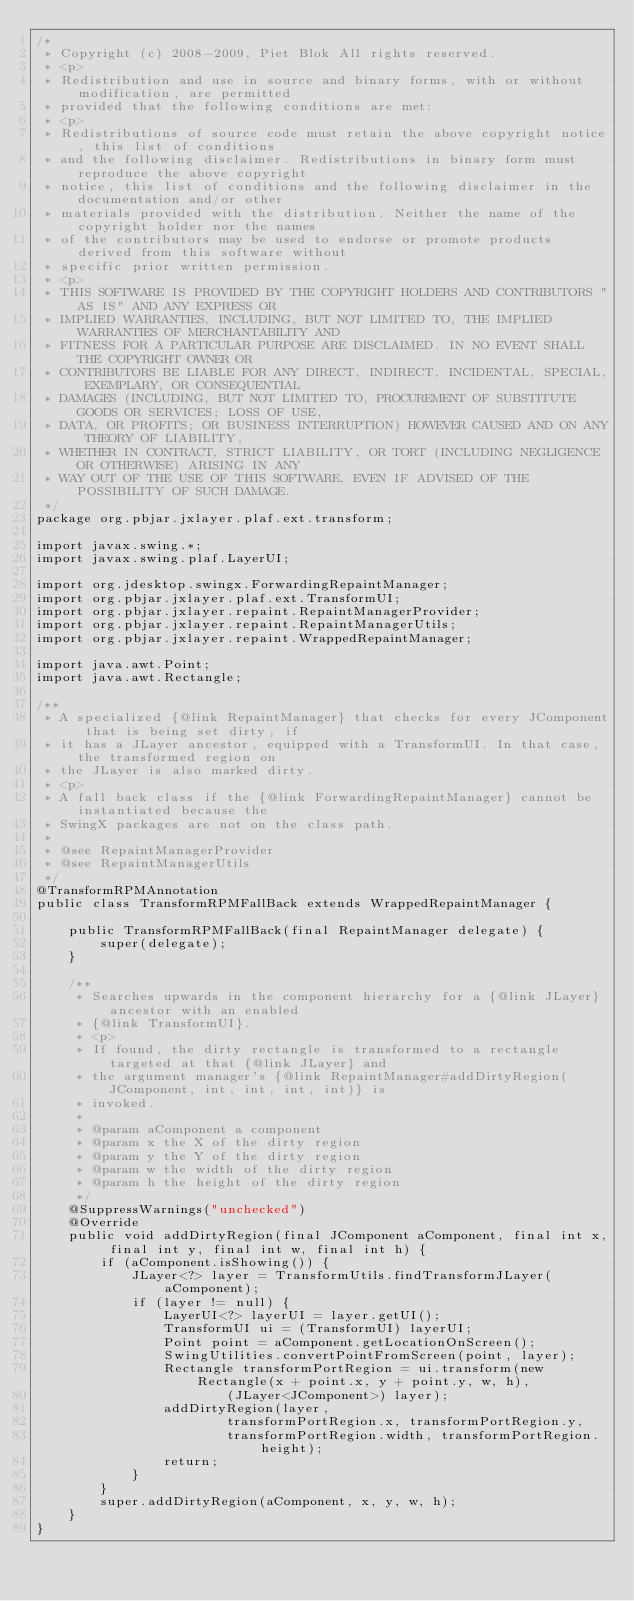Convert code to text. <code><loc_0><loc_0><loc_500><loc_500><_Java_>/*
 * Copyright (c) 2008-2009, Piet Blok All rights reserved.
 * <p>
 * Redistribution and use in source and binary forms, with or without modification, are permitted
 * provided that the following conditions are met:
 * <p>
 * Redistributions of source code must retain the above copyright notice, this list of conditions
 * and the following disclaimer. Redistributions in binary form must reproduce the above copyright
 * notice, this list of conditions and the following disclaimer in the documentation and/or other
 * materials provided with the distribution. Neither the name of the copyright holder nor the names
 * of the contributors may be used to endorse or promote products derived from this software without
 * specific prior written permission.
 * <p>
 * THIS SOFTWARE IS PROVIDED BY THE COPYRIGHT HOLDERS AND CONTRIBUTORS "AS IS" AND ANY EXPRESS OR
 * IMPLIED WARRANTIES, INCLUDING, BUT NOT LIMITED TO, THE IMPLIED WARRANTIES OF MERCHANTABILITY AND
 * FITNESS FOR A PARTICULAR PURPOSE ARE DISCLAIMED. IN NO EVENT SHALL THE COPYRIGHT OWNER OR
 * CONTRIBUTORS BE LIABLE FOR ANY DIRECT, INDIRECT, INCIDENTAL, SPECIAL, EXEMPLARY, OR CONSEQUENTIAL
 * DAMAGES (INCLUDING, BUT NOT LIMITED TO, PROCUREMENT OF SUBSTITUTE GOODS OR SERVICES; LOSS OF USE,
 * DATA, OR PROFITS; OR BUSINESS INTERRUPTION) HOWEVER CAUSED AND ON ANY THEORY OF LIABILITY,
 * WHETHER IN CONTRACT, STRICT LIABILITY, OR TORT (INCLUDING NEGLIGENCE OR OTHERWISE) ARISING IN ANY
 * WAY OUT OF THE USE OF THIS SOFTWARE, EVEN IF ADVISED OF THE POSSIBILITY OF SUCH DAMAGE.
 */
package org.pbjar.jxlayer.plaf.ext.transform;

import javax.swing.*;
import javax.swing.plaf.LayerUI;

import org.jdesktop.swingx.ForwardingRepaintManager;
import org.pbjar.jxlayer.plaf.ext.TransformUI;
import org.pbjar.jxlayer.repaint.RepaintManagerProvider;
import org.pbjar.jxlayer.repaint.RepaintManagerUtils;
import org.pbjar.jxlayer.repaint.WrappedRepaintManager;

import java.awt.Point;
import java.awt.Rectangle;

/**
 * A specialized {@link RepaintManager} that checks for every JComponent that is being set dirty, if
 * it has a JLayer ancestor, equipped with a TransformUI. In that case, the transformed region on
 * the JLayer is also marked dirty.
 * <p>
 * A fall back class if the {@link ForwardingRepaintManager} cannot be instantiated because the
 * SwingX packages are not on the class path.
 *
 * @see RepaintManagerProvider
 * @see RepaintManagerUtils
 */
@TransformRPMAnnotation
public class TransformRPMFallBack extends WrappedRepaintManager {

    public TransformRPMFallBack(final RepaintManager delegate) {
        super(delegate);
    }

    /**
     * Searches upwards in the component hierarchy for a {@link JLayer} ancestor with an enabled
     * {@link TransformUI}.
     * <p>
     * If found, the dirty rectangle is transformed to a rectangle targeted at that {@link JLayer} and
     * the argument manager's {@link RepaintManager#addDirtyRegion(JComponent, int, int, int, int)} is
     * invoked.
     *
     * @param aComponent a component
     * @param x the X of the dirty region
     * @param y the Y of the dirty region
     * @param w the width of the dirty region
     * @param h the height of the dirty region
     */
    @SuppressWarnings("unchecked")
    @Override
    public void addDirtyRegion(final JComponent aComponent, final int x, final int y, final int w, final int h) {
        if (aComponent.isShowing()) {
            JLayer<?> layer = TransformUtils.findTransformJLayer(aComponent);
            if (layer != null) {
                LayerUI<?> layerUI = layer.getUI();
                TransformUI ui = (TransformUI) layerUI;
                Point point = aComponent.getLocationOnScreen();
                SwingUtilities.convertPointFromScreen(point, layer);
                Rectangle transformPortRegion = ui.transform(new Rectangle(x + point.x, y + point.y, w, h),
                        (JLayer<JComponent>) layer);
                addDirtyRegion(layer,
                        transformPortRegion.x, transformPortRegion.y,
                        transformPortRegion.width, transformPortRegion.height);
                return;
            }
        }
        super.addDirtyRegion(aComponent, x, y, w, h);
    }
}
</code> 